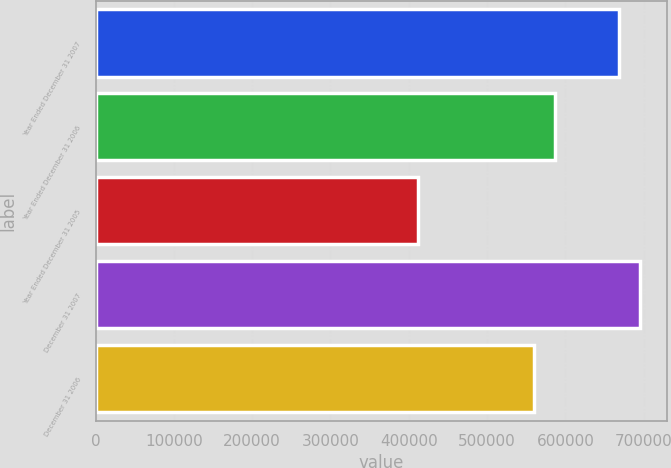Convert chart to OTSL. <chart><loc_0><loc_0><loc_500><loc_500><bar_chart><fcel>Year Ended December 31 2007<fcel>Year Ended December 31 2006<fcel>Year Ended December 31 2005<fcel>December 31 2007<fcel>December 31 2006<nl><fcel>668411<fcel>586722<fcel>412193<fcel>694951<fcel>560182<nl></chart> 